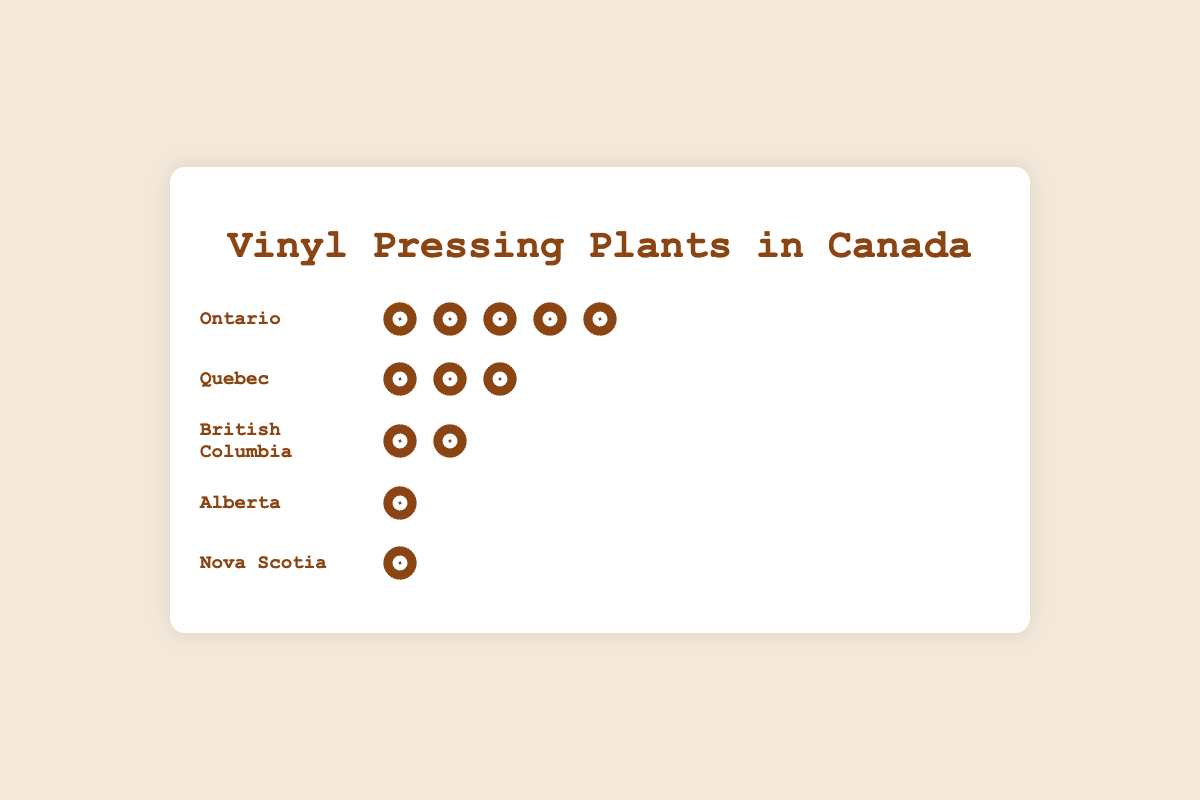How many provinces are depicted in the figure? Count the number of province names listed in the figure.
Answer: 5 Which province has the highest number of vinyl pressing plants? Observe which province has the most icons representing vinyl pressing plants.
Answer: Ontario How many more vinyl pressing plants does Ontario have compared to Quebec? Subtract the number of plants in Quebec from the number in Ontario: 5 - 3 = 2
Answer: 2 What is the total number of vinyl pressing plants shown in the figure? Sum the number of plants for all provinces: 5 (Ontario) + 3 (Quebec) + 2 (British Columbia) + 1 (Alberta) + 1 (Nova Scotia) = 12
Answer: 12 Which province(s) have only one vinyl pressing plant? Identify provinces with only one icon representing a vinyl pressing plant.
Answer: Alberta and Nova Scotia Which province has the second highest number of vinyl pressing plants? Identify the province with the second most icons after Ontario.
Answer: Quebec How many provinces have more than one vinyl pressing plant? Count the number of provinces where the number of plants is greater than one.
Answer: 3 Compare the number of vinyl pressing plants in British Columbia and Alberta. Which province has more? Compare the number of icons: British Columbia has 2, Alberta has 1.
Answer: British Columbia What is the average number of vinyl pressing plants per province? Divide the total number of plants by the number of provinces: 12/5 = 2.4
Answer: 2.4 What percentage of the total vinyl pressing plants are located in Ontario? Calculate the percentage using the formula: (number of plants in Ontario / total number of plants) * 100 = (5/12) * 100 ≈ 41.67%
Answer: 41.67% 